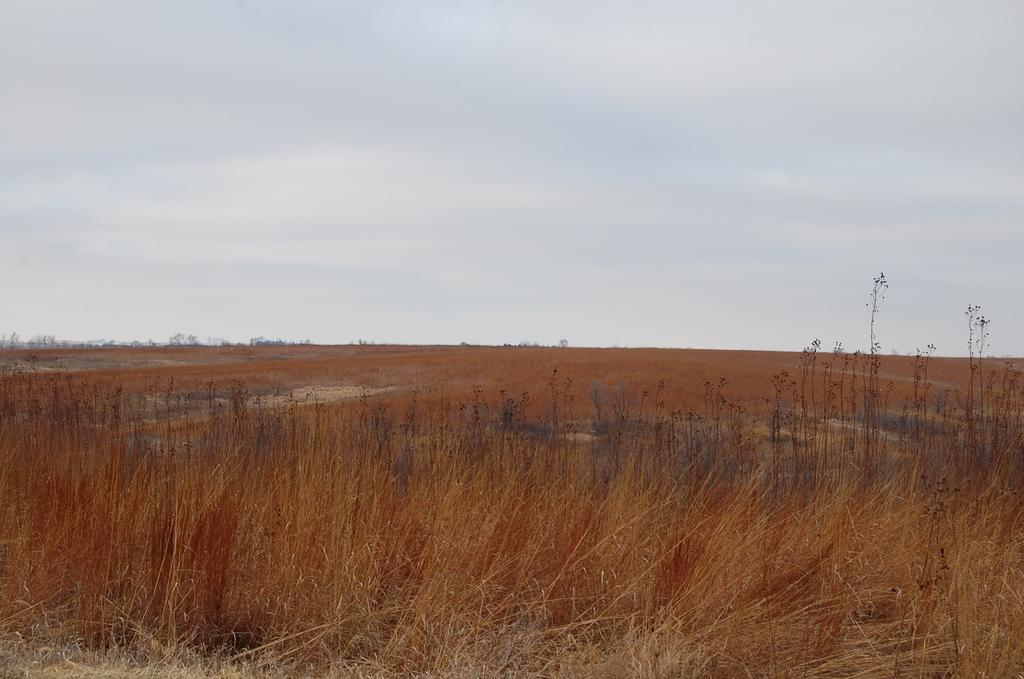What type of vegetation is at the bottom of the image? There is grass at the bottom of the image. What is located behind the grass in the image? There is land behind the grass. What can be seen at the top of the image? The sky is visible at the top of the image. What type of bells can be heard ringing in the image? There are no bells present in the image, and therefore no sound can be heard. What type of power source is visible in the image? There is no power source visible in the image. 